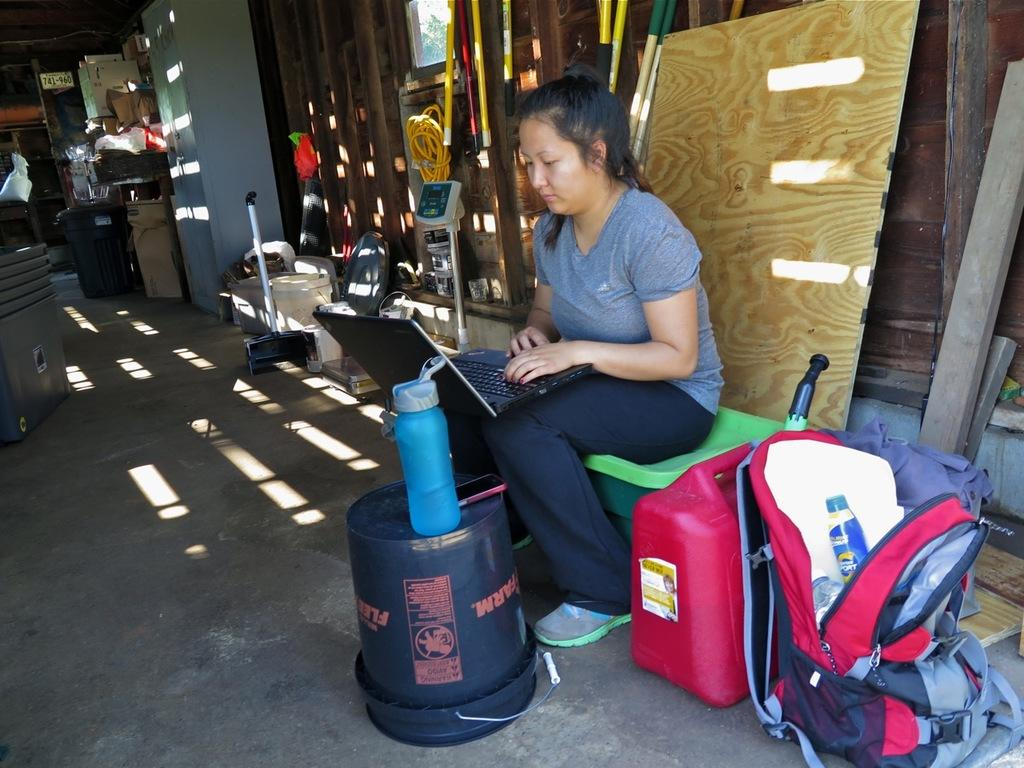Who is the main subject in the picture? There is a woman in the picture. What is the woman doing in the image? The woman is sitting and working with a laptop on her lap. What object is beside the woman? There is a bag beside the woman. Can you describe the room where the woman is sitting? There are different items visible in the room. What type of quilt is being used by the woman to cover the laptop? There is no quilt visible in the image; the woman is working with a laptop on her lap. Can you see a tramp in the room where the woman is sitting? There is no tramp present in the image; the focus is on the woman and her laptop. 